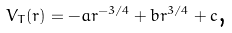<formula> <loc_0><loc_0><loc_500><loc_500>V _ { T } ( r ) = - a r ^ { - 3 / 4 } + b r ^ { 3 / 4 } + c \text {,}</formula> 